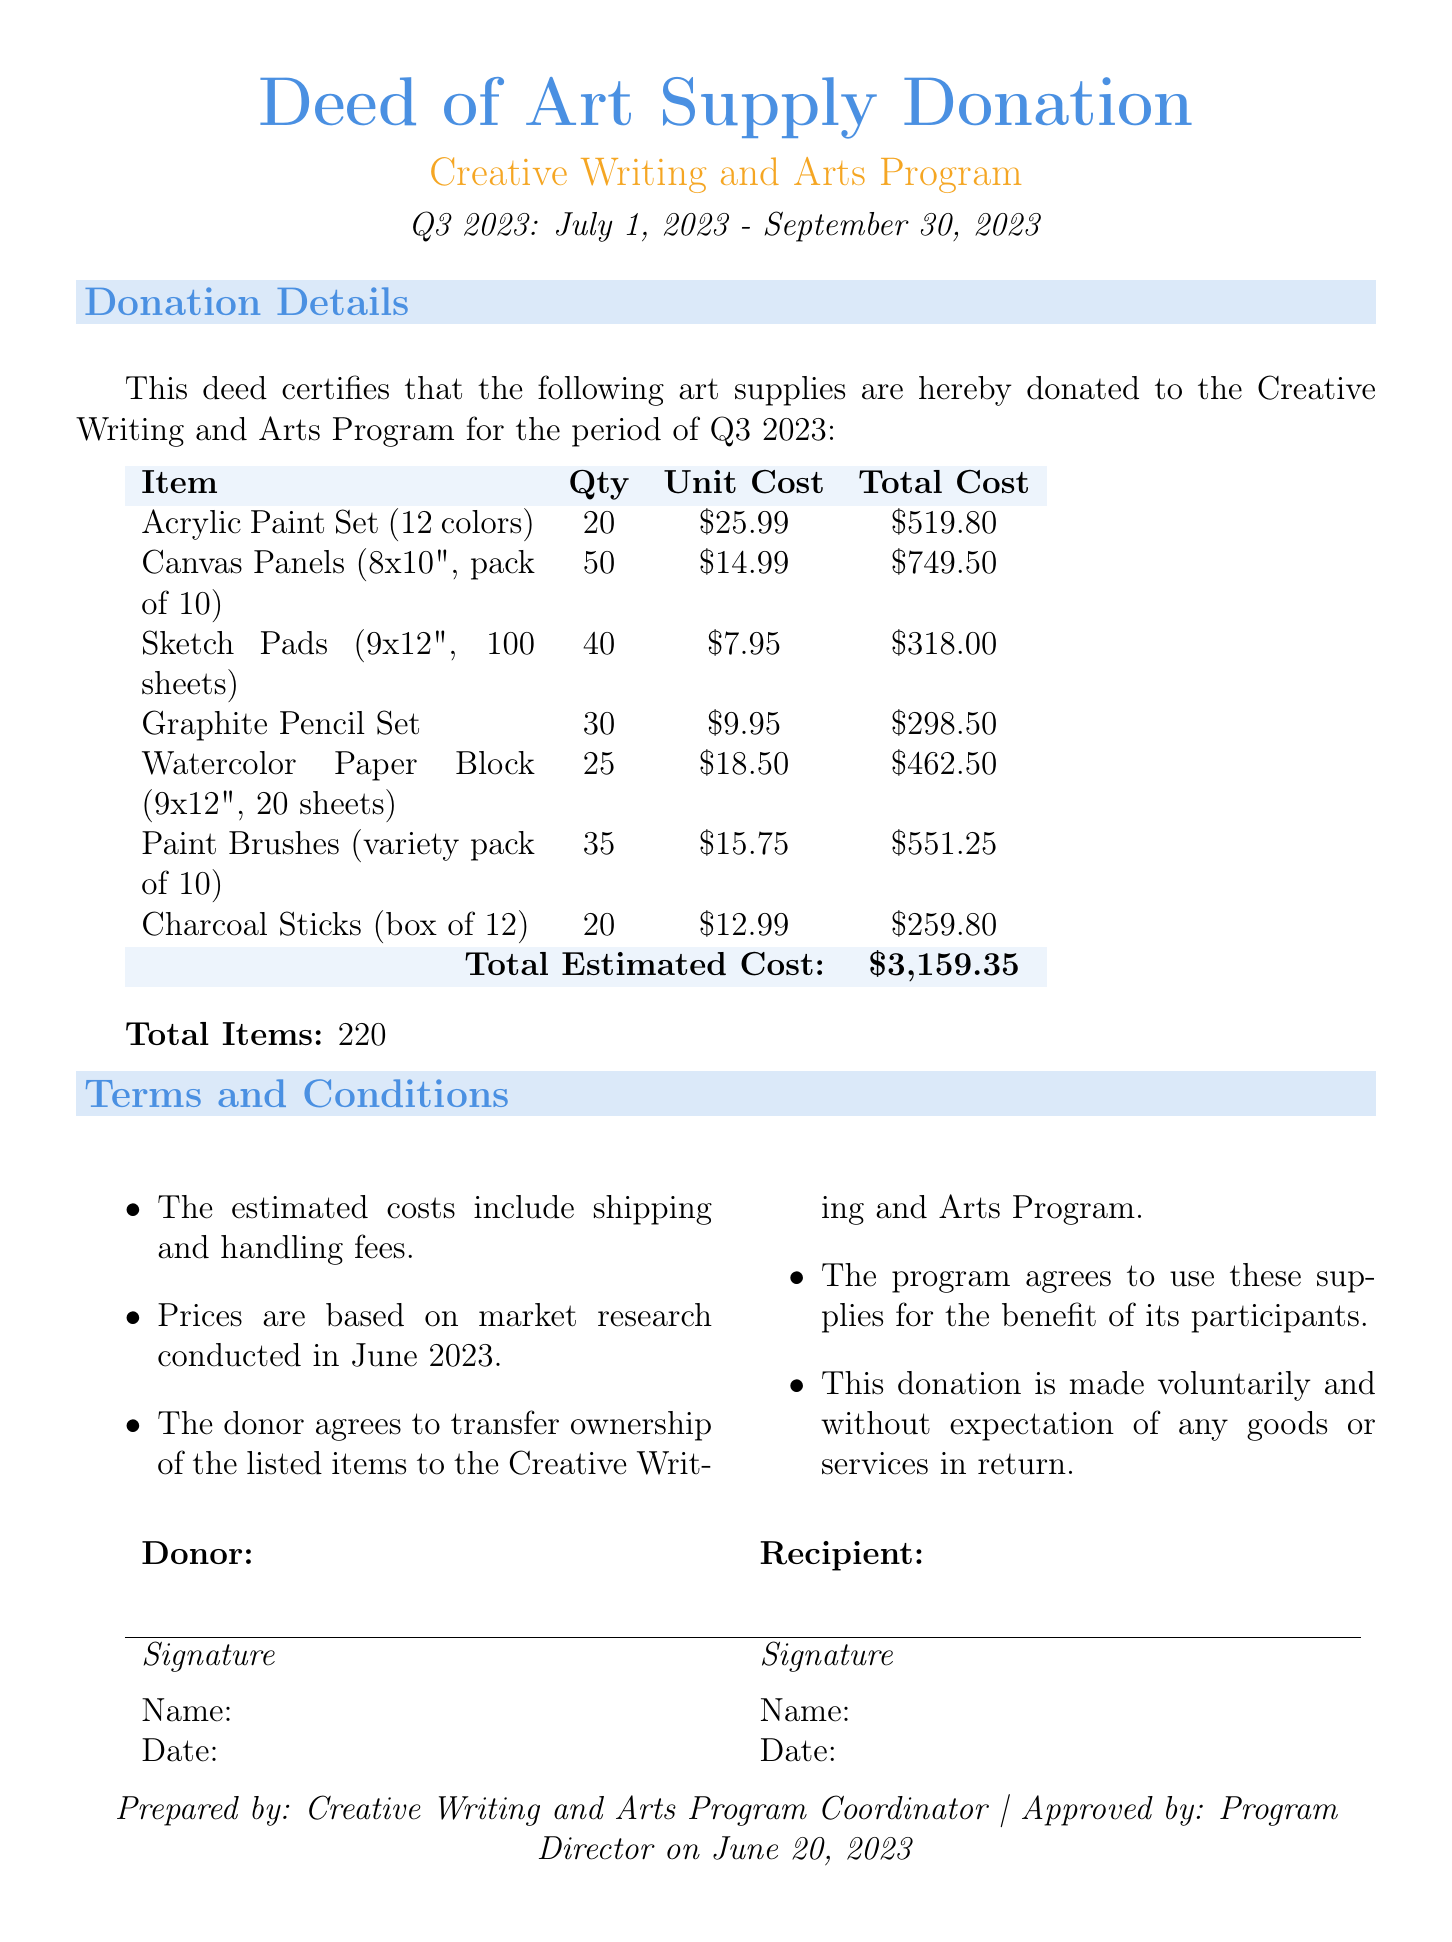What is the total estimated cost? The total estimated cost is stated at the bottom of the inventory table in the document.
Answer: $3,159.35 How many Canvas Panels are listed? The quantity of Canvas Panels can be found in the inventory table, along with item descriptions.
Answer: 50 What is the unit cost of the Paint Brushes? The unit cost for Paint Brushes is specified in the same row as its description in the inventory table.
Answer: $15.75 What is the total number of items? The total number of items is mentioned below the inventory table as a specific count.
Answer: 220 What is the date when the approval for the document was given? The approval date is mentioned at the bottom of the document, indicating when it was authorized.
Answer: June 20, 2023 Who is the recipient of the donation? The recipient is indicated in the section that outlines the details of the donation in the document.
Answer: Creative Writing and Arts Program What is included in the terms and conditions? The terms and conditions section outlines specific statements concerning the donation, which can be inferred from that section.
Answer: Estimated costs include shipping and handling fees What is the quantity of Sketch Pads? The quantity for Sketch Pads is detailed in the inventory table, specifically next to the item name.
Answer: 40 What is the item name with the lowest unit cost? The lowest unit cost can be determined by reviewing the unit costs listed in the inventory table.
Answer: Sketch Pads 